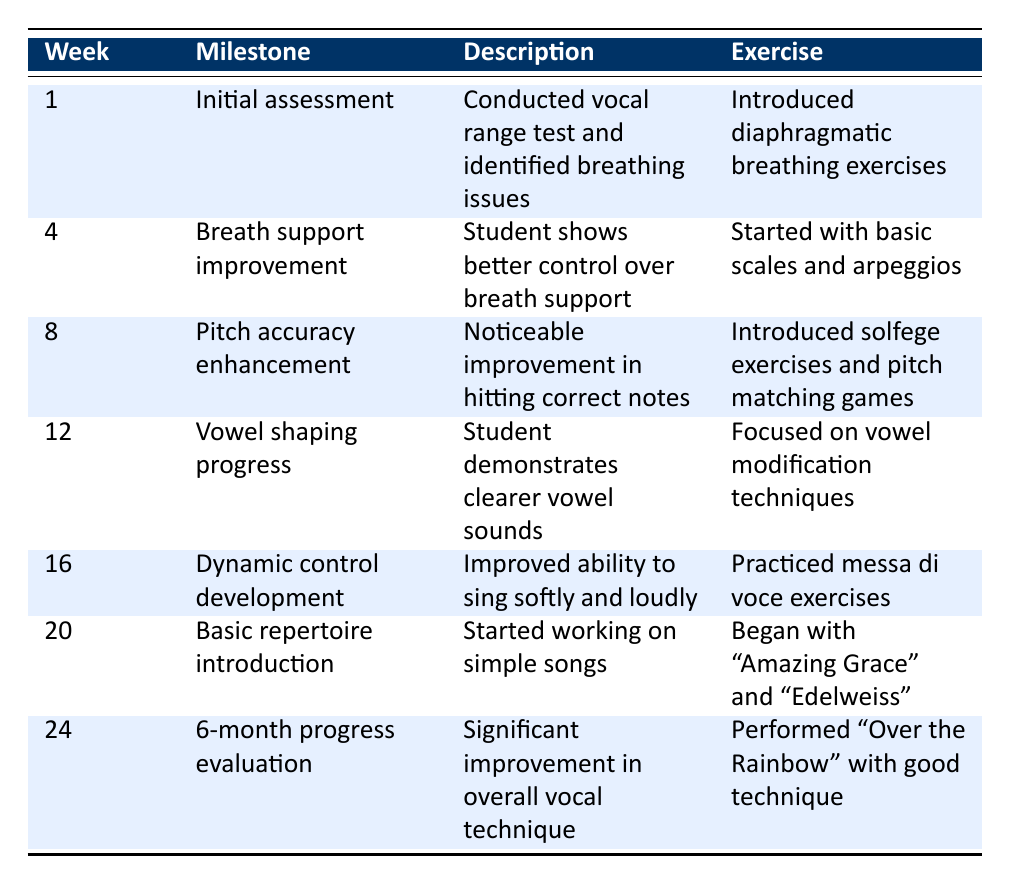What was the first milestone achieved by the student? The first milestone is found in week 1, which is "Initial assessment". It indicates the start of the student's vocal journey.
Answer: Initial assessment How many weeks did it take for the student to improve their breath support? The improvement in breath support is noted in week 4. Since the first assessment was at week 1, it took a total of 3 weeks (week 4 - week 1) for the student to show improvement.
Answer: 3 weeks Did the student work on pitch accuracy before vowel shaping techniques? Yes, the student worked on pitch accuracy enhancement in week 8 before vowel shaping progress in week 12, indicating that pitch accuracy was addressed first.
Answer: Yes What specific exercise was introduced for vowel shaping progress? To see the exercise for vowels, we refer to week 12, which indicates the exercise was focused on vowel modification techniques.
Answer: Vowel modification techniques What is the milestone achieved in week 20? Week 20's milestone is "Basic repertoire introduction", which signifies the student's entry into singing simple songs.
Answer: Basic repertoire introduction How much improvement did the student demonstrate from week 1 to week 24? From week 1 (Initial assessment) to week 24 (6-month progress evaluation), the student has shown significant improvement, as noted in the description for week 24. This entails growth in overall vocal technique and performance readiness.
Answer: Significant improvement What exercises were used to practice dynamic control development? In week 16, the exercise to develop dynamic control was practicing "messa di voce exercises."
Answer: Messa di voce exercises In which week did the student perform a song with good technique? In week 24, the student performed "Over the Rainbow" with good technique, marking the culmination of their progress in vocal training.
Answer: Week 24 How many weeks were dedicated to breath support exercises before pitch accuracy was introduced? The student began breath support exercises in week 4 and transitioned to pitch accuracy in week 8, leading to a total of 4 weeks (week 4 to week 8) being dedicated to breath support.
Answer: 4 weeks 